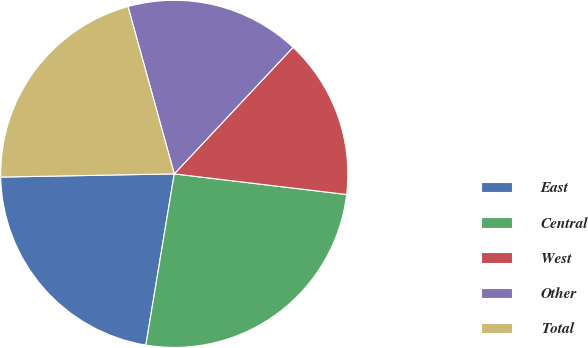<chart> <loc_0><loc_0><loc_500><loc_500><pie_chart><fcel>East<fcel>Central<fcel>West<fcel>Other<fcel>Total<nl><fcel>22.09%<fcel>25.72%<fcel>14.9%<fcel>16.29%<fcel>21.0%<nl></chart> 